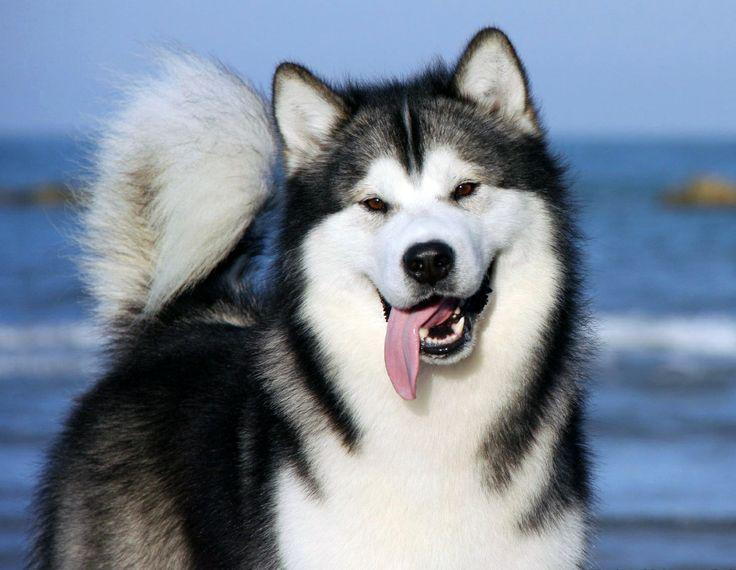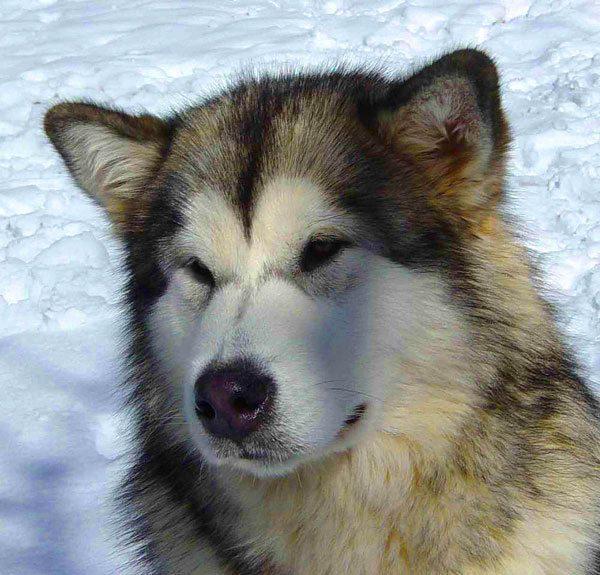The first image is the image on the left, the second image is the image on the right. Analyze the images presented: Is the assertion "Each image contains one husky dog, but only one of the images features a dog with its tongue hanging out." valid? Answer yes or no. Yes. The first image is the image on the left, the second image is the image on the right. Given the left and right images, does the statement "There are exactly two dogs in the snow." hold true? Answer yes or no. No. 